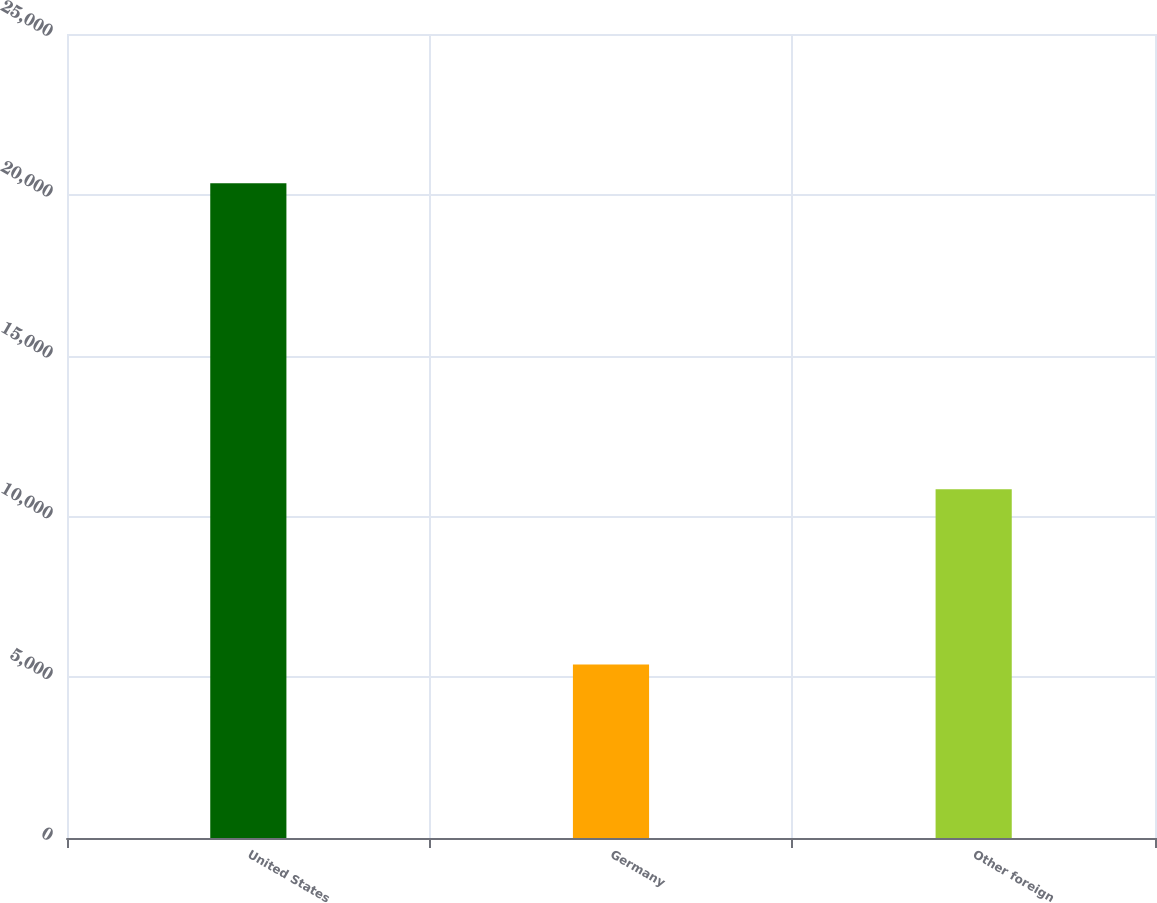Convert chart. <chart><loc_0><loc_0><loc_500><loc_500><bar_chart><fcel>United States<fcel>Germany<fcel>Other foreign<nl><fcel>20358<fcel>5396<fcel>10842<nl></chart> 